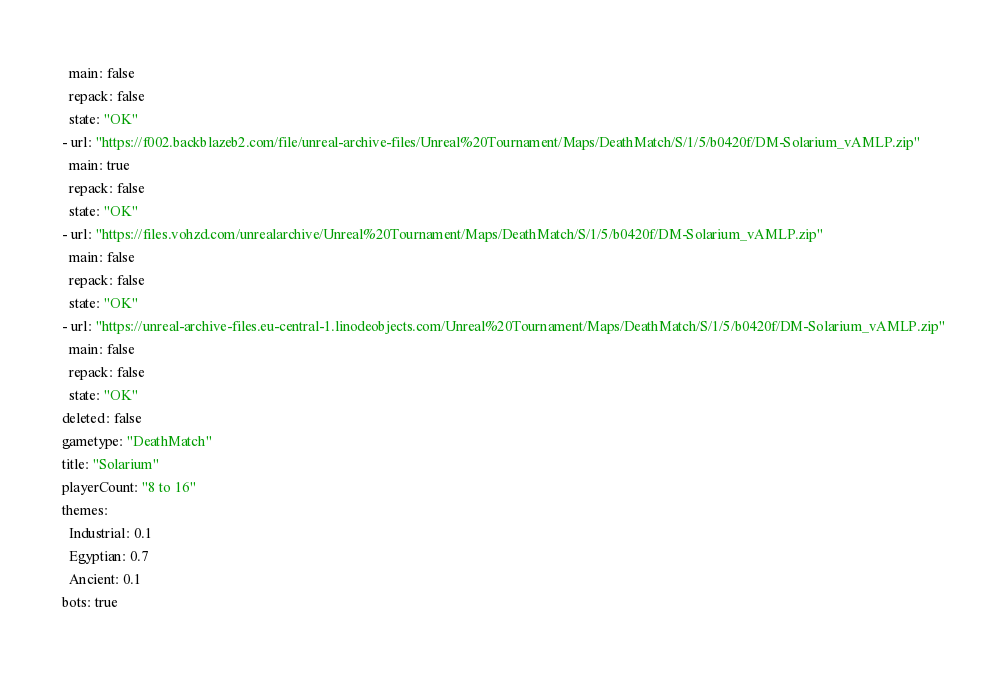Convert code to text. <code><loc_0><loc_0><loc_500><loc_500><_YAML_>  main: false
  repack: false
  state: "OK"
- url: "https://f002.backblazeb2.com/file/unreal-archive-files/Unreal%20Tournament/Maps/DeathMatch/S/1/5/b0420f/DM-Solarium_vAMLP.zip"
  main: true
  repack: false
  state: "OK"
- url: "https://files.vohzd.com/unrealarchive/Unreal%20Tournament/Maps/DeathMatch/S/1/5/b0420f/DM-Solarium_vAMLP.zip"
  main: false
  repack: false
  state: "OK"
- url: "https://unreal-archive-files.eu-central-1.linodeobjects.com/Unreal%20Tournament/Maps/DeathMatch/S/1/5/b0420f/DM-Solarium_vAMLP.zip"
  main: false
  repack: false
  state: "OK"
deleted: false
gametype: "DeathMatch"
title: "Solarium"
playerCount: "8 to 16"
themes:
  Industrial: 0.1
  Egyptian: 0.7
  Ancient: 0.1
bots: true
</code> 